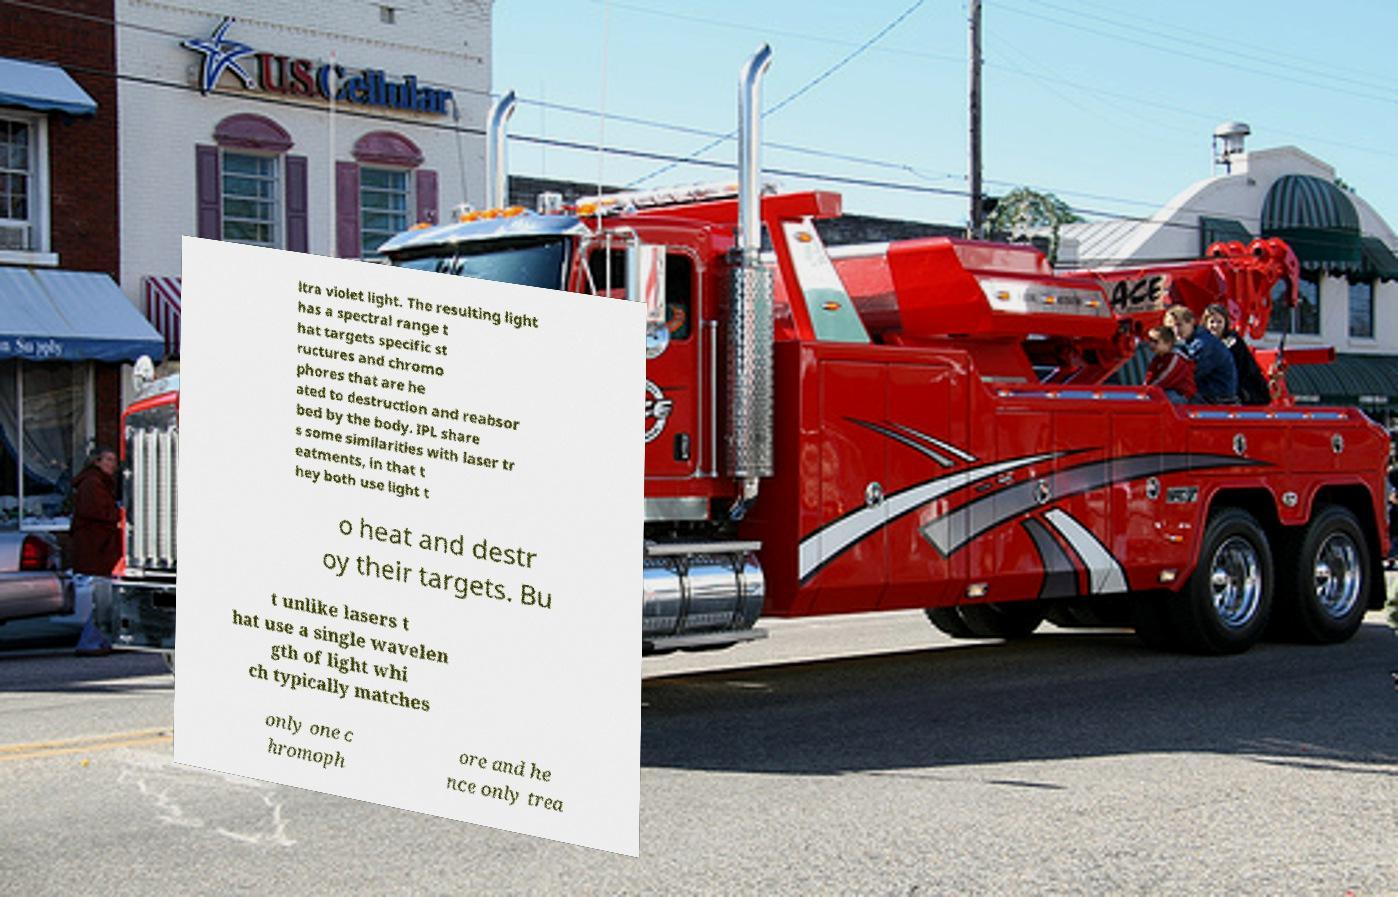Please identify and transcribe the text found in this image. ltra violet light. The resulting light has a spectral range t hat targets specific st ructures and chromo phores that are he ated to destruction and reabsor bed by the body. IPL share s some similarities with laser tr eatments, in that t hey both use light t o heat and destr oy their targets. Bu t unlike lasers t hat use a single wavelen gth of light whi ch typically matches only one c hromoph ore and he nce only trea 